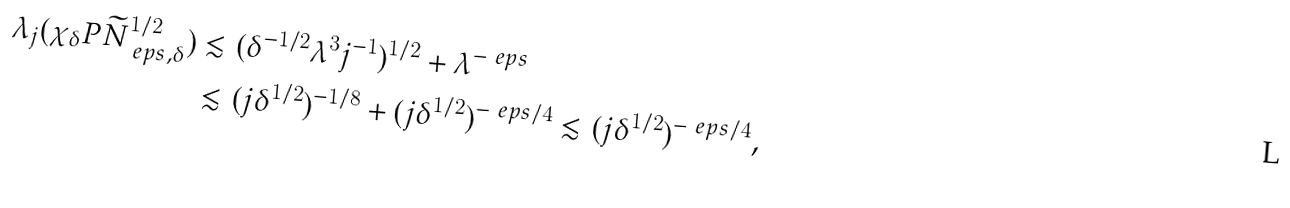<formula> <loc_0><loc_0><loc_500><loc_500>\lambda _ { j } ( \chi _ { \delta } P \widetilde { N } ^ { 1 / 2 } _ { \ e p s , \delta } ) & \lesssim ( \delta ^ { - 1 / 2 } \lambda ^ { 3 } j ^ { - 1 } ) ^ { 1 / 2 } + \lambda ^ { - \ e p s } \\ & \lesssim ( j \delta ^ { 1 / 2 } ) ^ { - 1 / 8 } + ( j \delta ^ { 1 / 2 } ) ^ { - \ e p s / 4 } \lesssim ( j \delta ^ { 1 / 2 } ) ^ { - \ e p s / 4 } ,</formula> 